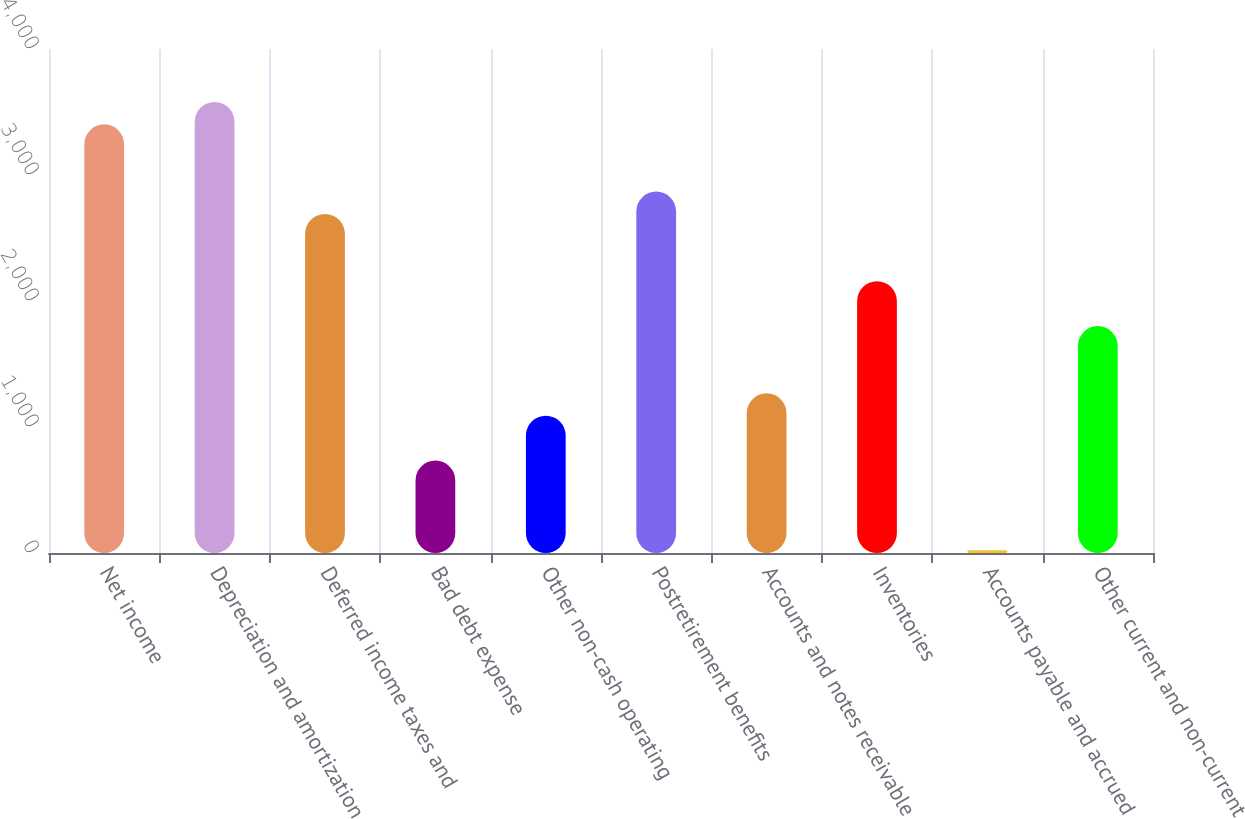Convert chart to OTSL. <chart><loc_0><loc_0><loc_500><loc_500><bar_chart><fcel>Net income<fcel>Depreciation and amortization<fcel>Deferred income taxes and<fcel>Bad debt expense<fcel>Other non-cash operating<fcel>Postretirement benefits<fcel>Accounts and notes receivable<fcel>Inventories<fcel>Accounts payable and accrued<fcel>Other current and non-current<nl><fcel>3402.1<fcel>3580<fcel>2690.5<fcel>733.6<fcel>1089.4<fcel>2868.4<fcel>1267.3<fcel>2156.8<fcel>22<fcel>1801<nl></chart> 